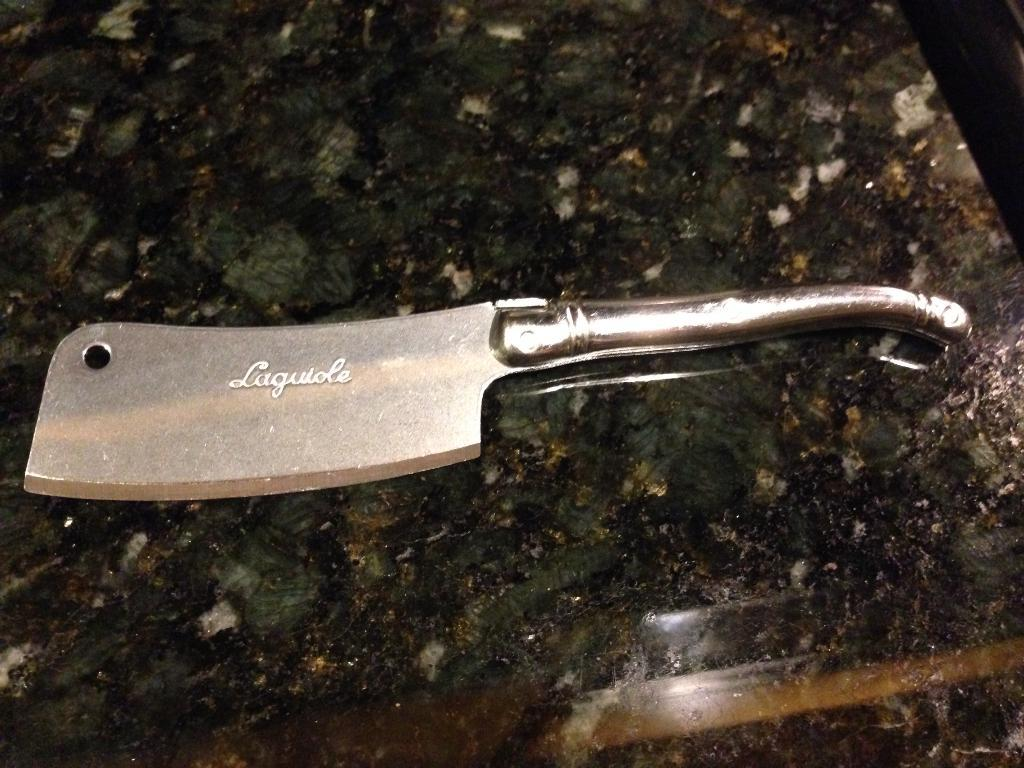What type of material is the object in the image made of? The object in the image is made of metal. What can be found on the metal object? The metal object has text on it. What is the surface beneath the metal object? The metal object is placed on a marble surface. What direction does the thing in the image point towards? There is no "thing" mentioned in the facts, and the metal object does not have a direction it points towards. 